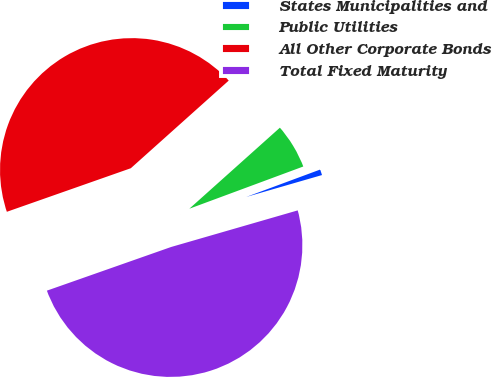Convert chart to OTSL. <chart><loc_0><loc_0><loc_500><loc_500><pie_chart><fcel>States Municipalities and<fcel>Public Utilities<fcel>All Other Corporate Bonds<fcel>Total Fixed Maturity<nl><fcel>1.17%<fcel>5.97%<fcel>43.76%<fcel>49.1%<nl></chart> 